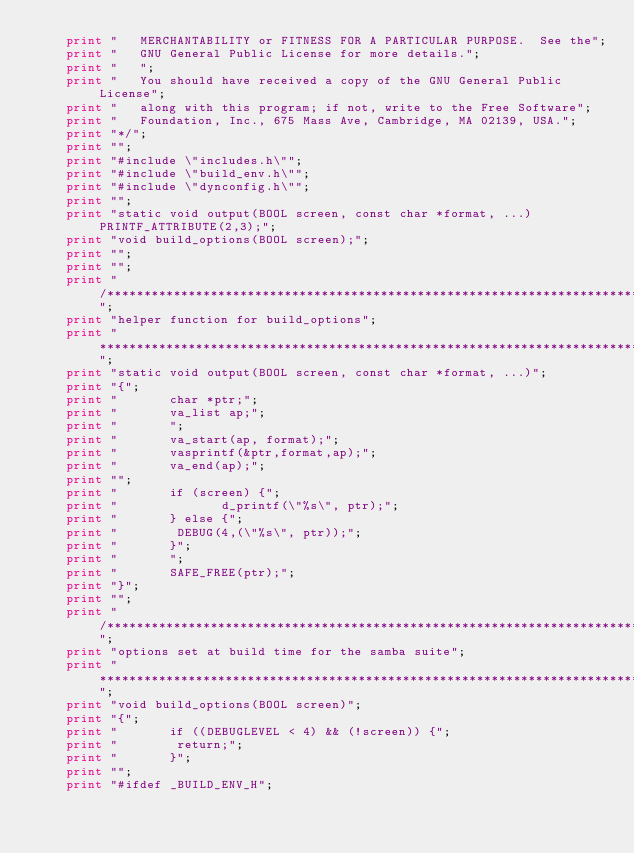<code> <loc_0><loc_0><loc_500><loc_500><_Awk_>	print "   MERCHANTABILITY or FITNESS FOR A PARTICULAR PURPOSE.  See the";
	print "   GNU General Public License for more details.";
	print "   ";
	print "   You should have received a copy of the GNU General Public License";
	print "   along with this program; if not, write to the Free Software";
	print "   Foundation, Inc., 675 Mass Ave, Cambridge, MA 02139, USA.";
	print "*/";
	print "";
	print "#include \"includes.h\"";
	print "#include \"build_env.h\"";
	print "#include \"dynconfig.h\"";
	print "";
	print "static void output(BOOL screen, const char *format, ...) PRINTF_ATTRIBUTE(2,3);";
	print "void build_options(BOOL screen);";
	print "";
	print "";
	print "/****************************************************************************";
	print "helper function for build_options";
	print "****************************************************************************/";
	print "static void output(BOOL screen, const char *format, ...)";
	print "{";
	print "       char *ptr;";
	print "       va_list ap;";
	print "       ";
	print "       va_start(ap, format);";
	print "       vasprintf(&ptr,format,ap);";
	print "       va_end(ap);";
	print "";
	print "       if (screen) {";
	print "              d_printf(\"%s\", ptr);";
	print "       } else {";
	print "	       DEBUG(4,(\"%s\", ptr));";
	print "       }";
	print "       ";
	print "       SAFE_FREE(ptr);";
	print "}";
	print "";
	print "/****************************************************************************";
	print "options set at build time for the samba suite";
	print "****************************************************************************/";
	print "void build_options(BOOL screen)";
	print "{";
	print "       if ((DEBUGLEVEL < 4) && (!screen)) {";
	print "	       return;";
	print "       }";
	print "";
	print "#ifdef _BUILD_ENV_H";</code> 